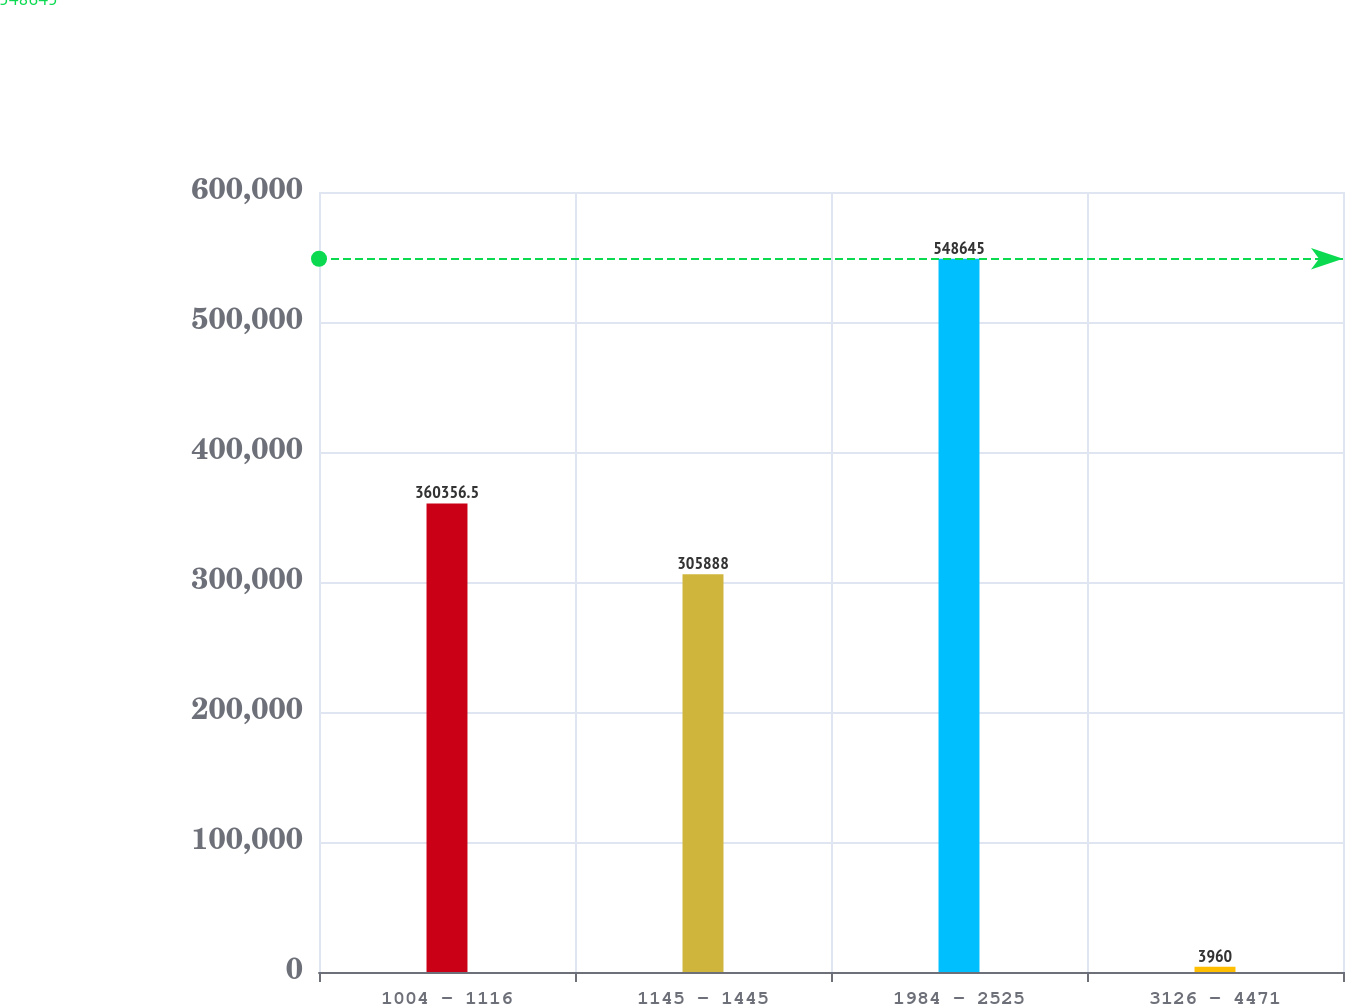<chart> <loc_0><loc_0><loc_500><loc_500><bar_chart><fcel>1004 - 1116<fcel>1145 - 1445<fcel>1984 - 2525<fcel>3126 - 4471<nl><fcel>360356<fcel>305888<fcel>548645<fcel>3960<nl></chart> 